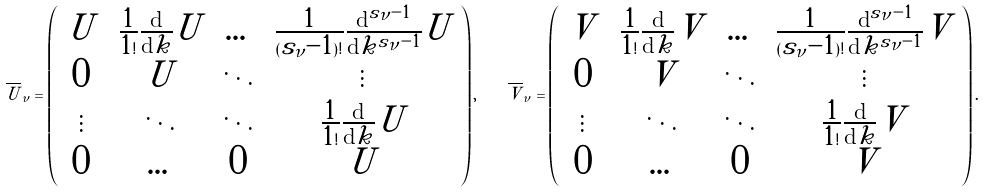<formula> <loc_0><loc_0><loc_500><loc_500>\overline { U } _ { \nu } = \left ( \begin{array} { c c c c } U \, & \frac { 1 } { 1 ! } \frac { \text {d} } { \text {d} k } U & \dots & \frac { 1 } { ( s _ { \nu } - 1 ) ! } \frac { \text {d} ^ { s _ { \nu } - 1 } } { \text {d} k ^ { s _ { \nu } - 1 } } U \\ 0 \, & U & \ddots & \vdots \\ \vdots \, & \ddots & \ddots & \frac { 1 } { 1 ! } \frac { \text {d} } { \text {d} k } U \\ 0 \, & \dots & 0 & U \end{array} \right ) , \quad \overline { V } _ { \nu } = \left ( \begin{array} { c c c c } V \, & \frac { 1 } { 1 ! } \frac { \text {d} } { \text {d} k } V & \dots & \frac { 1 } { ( s _ { \nu } - 1 ) ! } \frac { \text {d} ^ { s _ { \nu } - 1 } } { \text {d} k ^ { s _ { \nu } - 1 } } V \\ 0 \, & V & \ddots & \vdots \\ \vdots \, & \ddots & \ddots & \frac { 1 } { 1 ! } \frac { \text {d} } { \text {d} k } V \\ 0 \, & \dots & 0 & V \end{array} \right ) .</formula> 